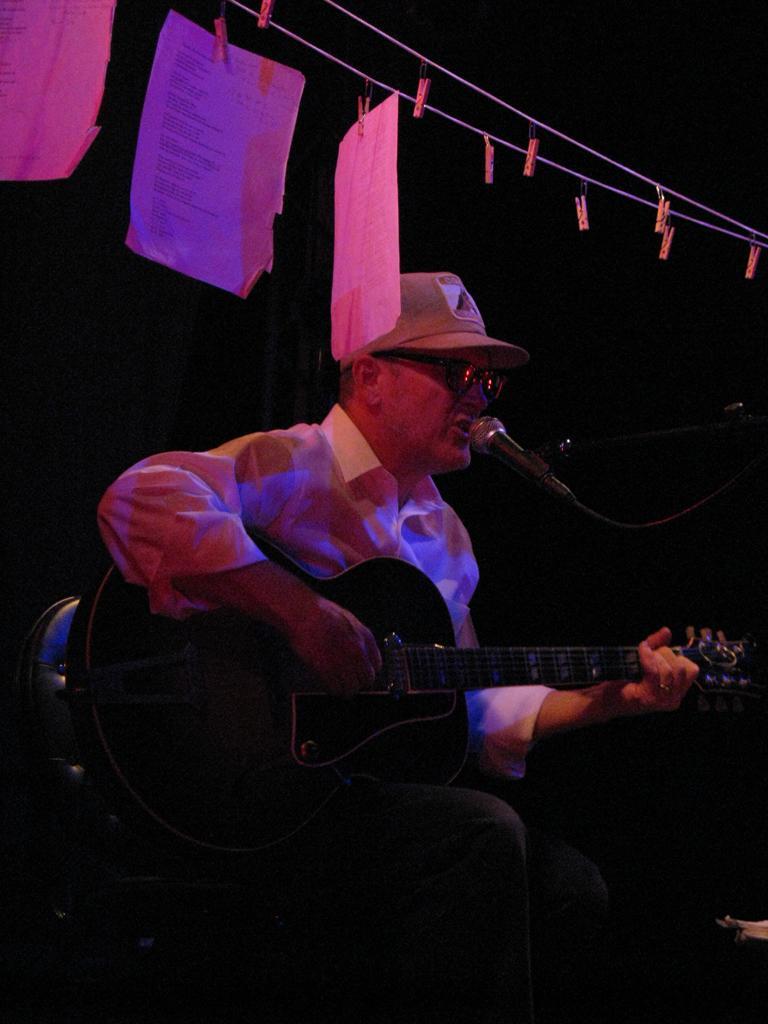Please provide a concise description of this image. As we can see in the image there are papers and a man holding guitar. In front of him there is a mic. 